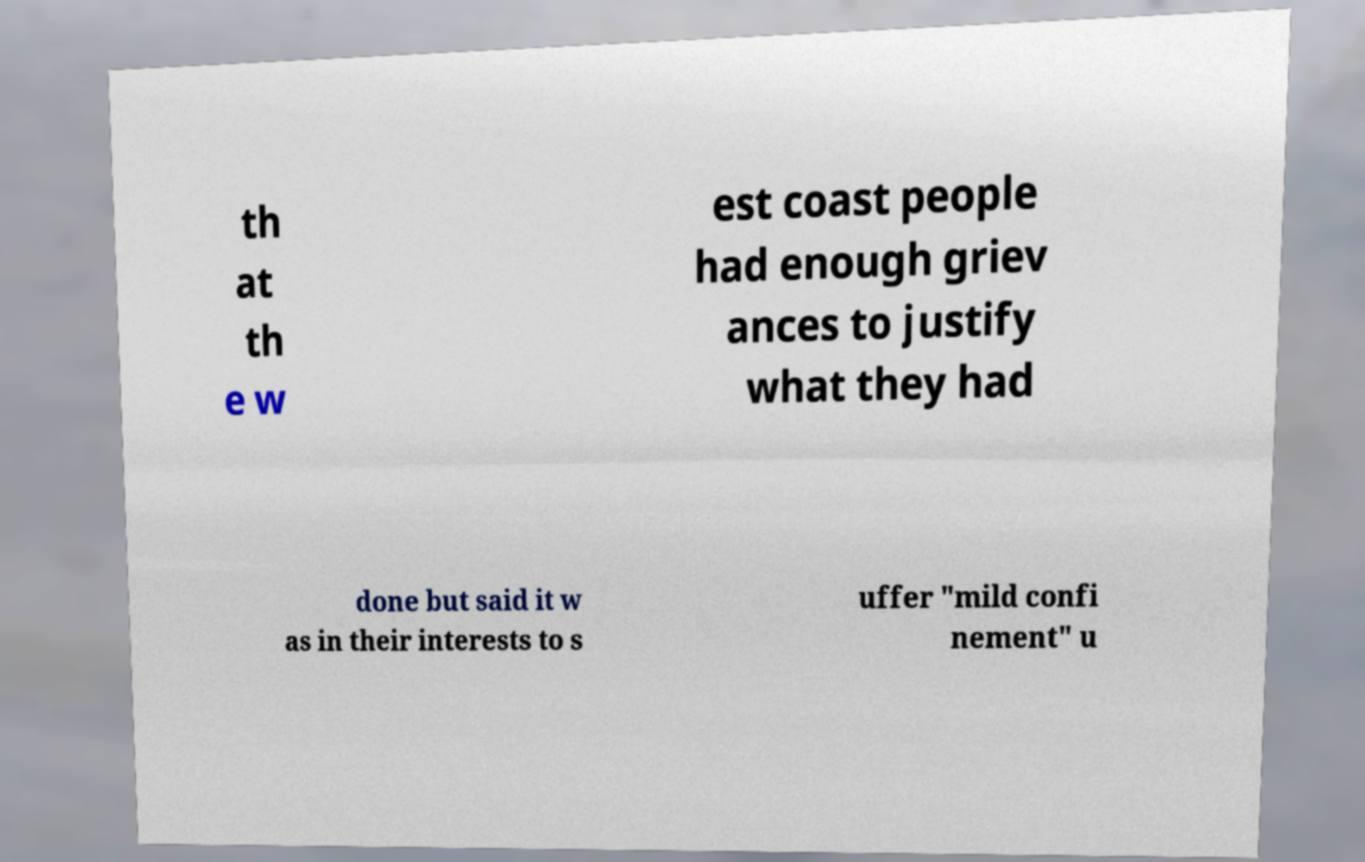Can you accurately transcribe the text from the provided image for me? th at th e w est coast people had enough griev ances to justify what they had done but said it w as in their interests to s uffer "mild confi nement" u 